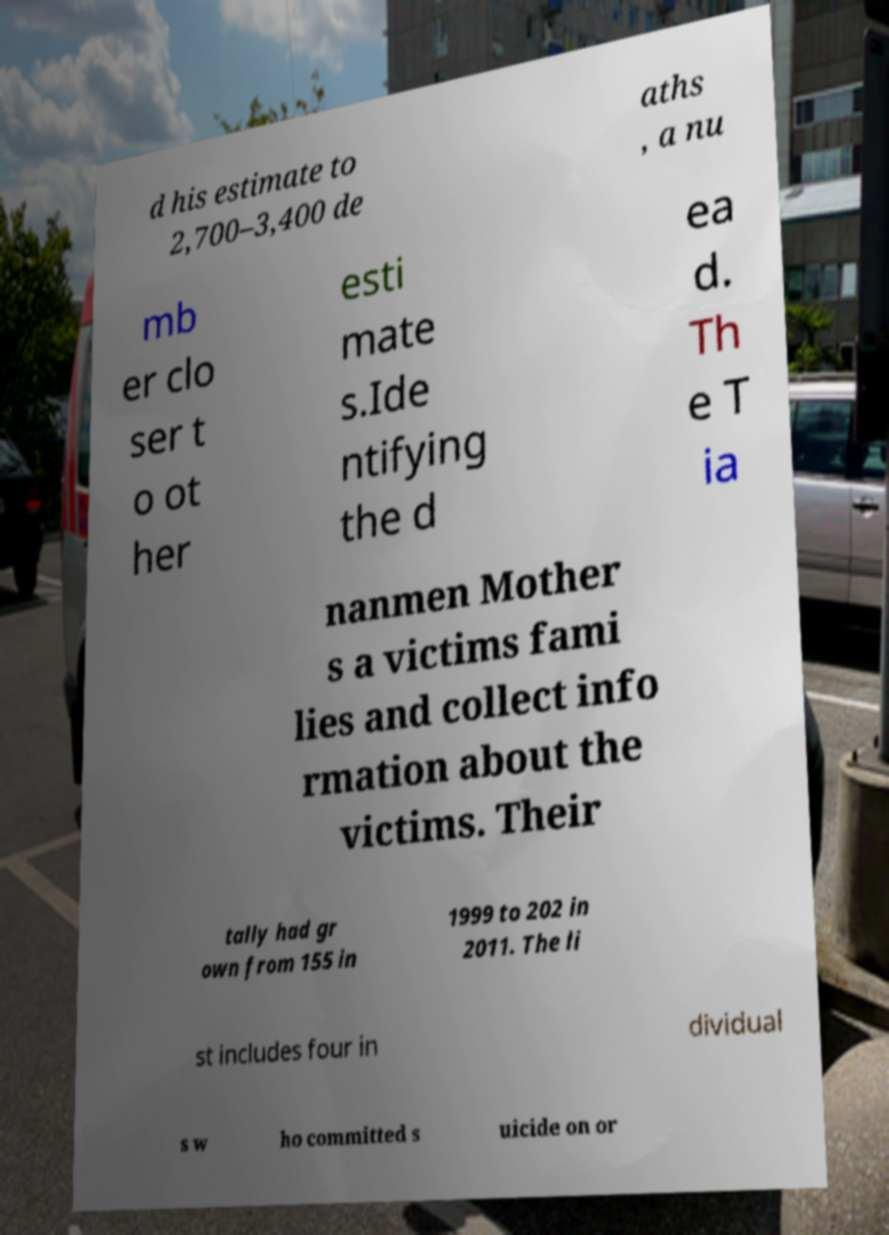What messages or text are displayed in this image? I need them in a readable, typed format. d his estimate to 2,700–3,400 de aths , a nu mb er clo ser t o ot her esti mate s.Ide ntifying the d ea d. Th e T ia nanmen Mother s a victims fami lies and collect info rmation about the victims. Their tally had gr own from 155 in 1999 to 202 in 2011. The li st includes four in dividual s w ho committed s uicide on or 